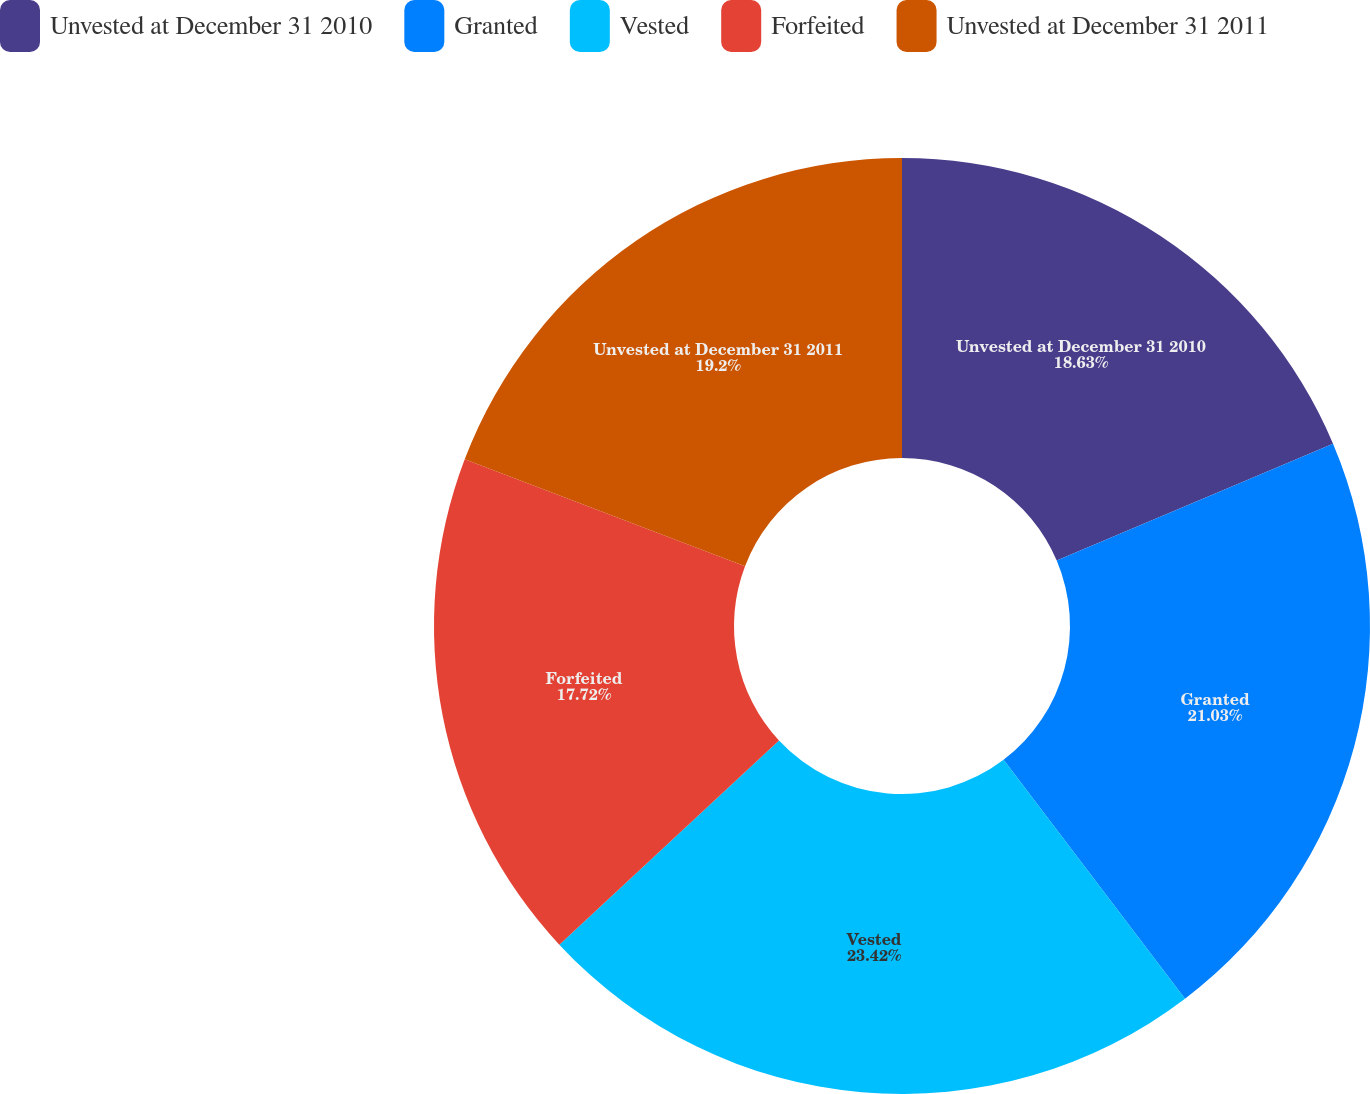Convert chart. <chart><loc_0><loc_0><loc_500><loc_500><pie_chart><fcel>Unvested at December 31 2010<fcel>Granted<fcel>Vested<fcel>Forfeited<fcel>Unvested at December 31 2011<nl><fcel>18.63%<fcel>21.03%<fcel>23.41%<fcel>17.72%<fcel>19.2%<nl></chart> 